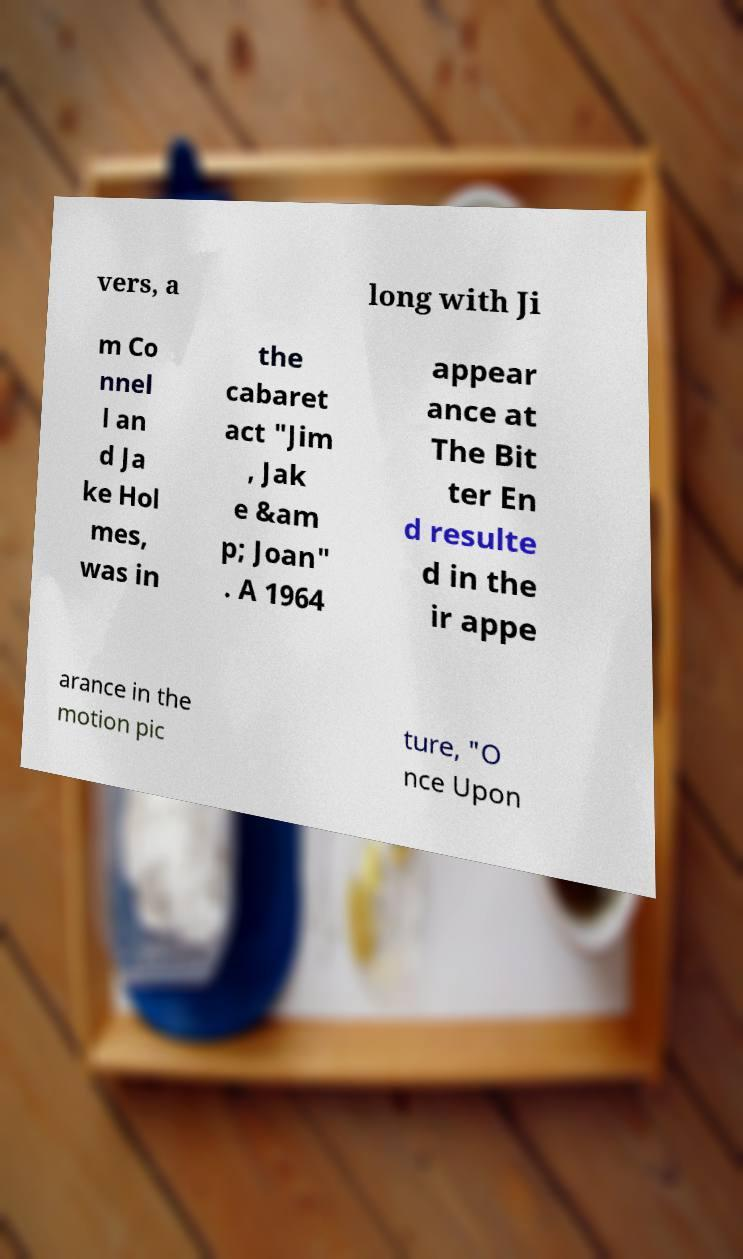Could you extract and type out the text from this image? vers, a long with Ji m Co nnel l an d Ja ke Hol mes, was in the cabaret act "Jim , Jak e &am p; Joan" . A 1964 appear ance at The Bit ter En d resulte d in the ir appe arance in the motion pic ture, "O nce Upon 